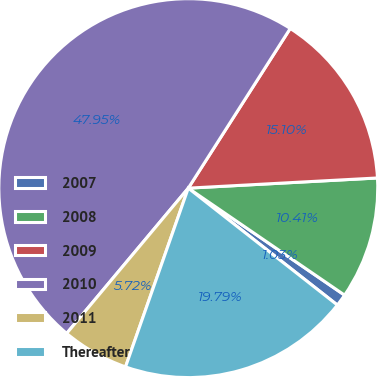Convert chart. <chart><loc_0><loc_0><loc_500><loc_500><pie_chart><fcel>2007<fcel>2008<fcel>2009<fcel>2010<fcel>2011<fcel>Thereafter<nl><fcel>1.03%<fcel>10.41%<fcel>15.1%<fcel>47.95%<fcel>5.72%<fcel>19.79%<nl></chart> 